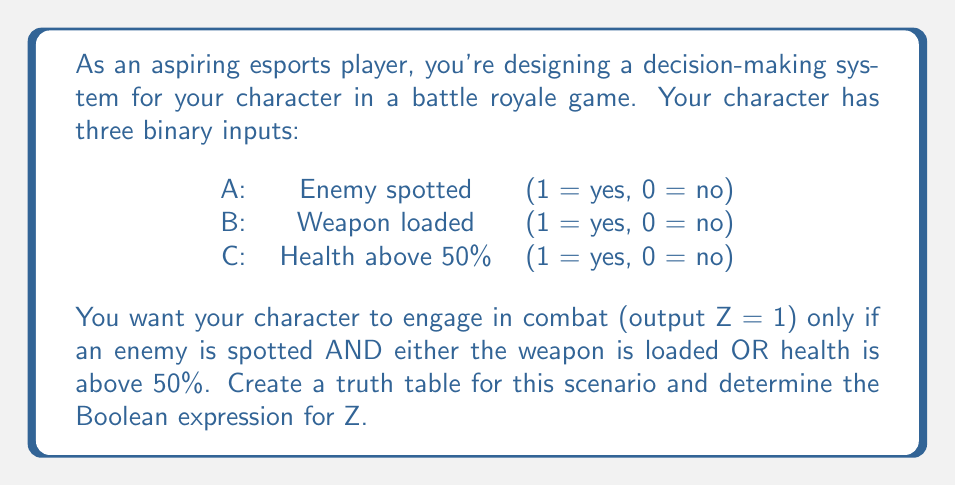Can you solve this math problem? Let's approach this step-by-step:

1) First, we need to create a truth table with all possible combinations of inputs A, B, and C:

   | A | B | C | Z |
   |---|---|---|---|
   | 0 | 0 | 0 | 0 |
   | 0 | 0 | 1 | 0 |
   | 0 | 1 | 0 | 0 |
   | 0 | 1 | 1 | 0 |
   | 1 | 0 | 0 | 0 |
   | 1 | 0 | 1 | 1 |
   | 1 | 1 | 0 | 1 |
   | 1 | 1 | 1 | 1 |

2) Now, we fill in the Z column based on the given conditions:
   - Z = 1 only if A = 1 (enemy spotted) AND (B = 1 OR C = 1)

3) From the truth table, we can derive the Boolean expression for Z:

   $$Z = A \cdot (B + C)$$

   Where:
   - $\cdot$ represents AND
   - $+$ represents OR

4) This expression can be read as: "Z is true when A is true AND either B or C (or both) are true."

5) We can verify this expression by checking it against our truth table:
   - When A = 1 and either B = 1 or C = 1 (or both), Z = 1
   - In all other cases, Z = 0

Thus, this Boolean expression correctly models the desired in-game decision-making scenario.
Answer: $$Z = A \cdot (B + C)$$ 